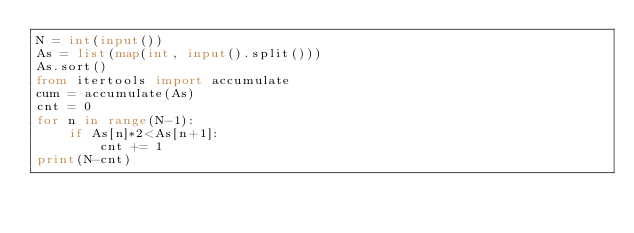Convert code to text. <code><loc_0><loc_0><loc_500><loc_500><_Python_>N = int(input())
As = list(map(int, input().split()))
As.sort()
from itertools import accumulate
cum = accumulate(As)
cnt = 0
for n in range(N-1):
    if As[n]*2<As[n+1]:
        cnt += 1
print(N-cnt)
    

</code> 